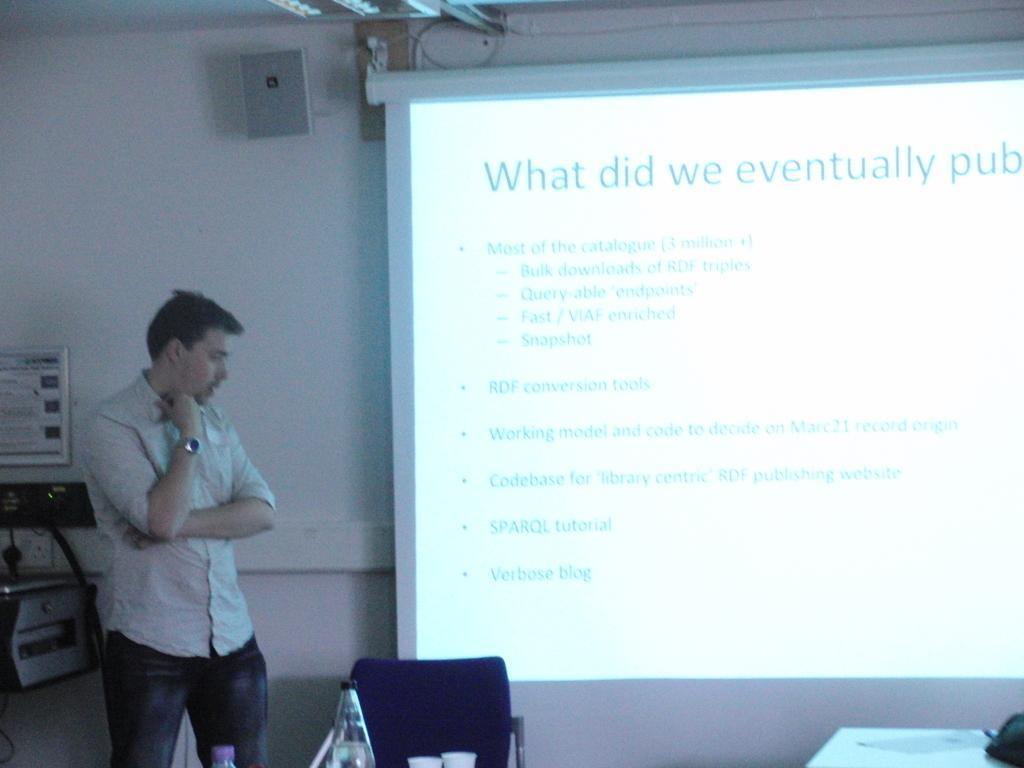Describe this image in one or two sentences. In this picture we can see a man is standing on the floor and on the left side of the man there are some machines and on the right side of the man there is a bottle, cups on an object. Behind the man there is a projector screen and a wall with a speaker. 